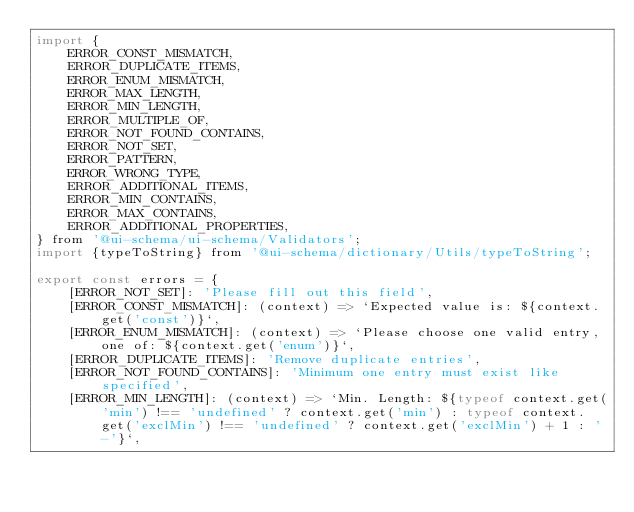Convert code to text. <code><loc_0><loc_0><loc_500><loc_500><_JavaScript_>import {
    ERROR_CONST_MISMATCH,
    ERROR_DUPLICATE_ITEMS,
    ERROR_ENUM_MISMATCH,
    ERROR_MAX_LENGTH,
    ERROR_MIN_LENGTH,
    ERROR_MULTIPLE_OF,
    ERROR_NOT_FOUND_CONTAINS,
    ERROR_NOT_SET,
    ERROR_PATTERN,
    ERROR_WRONG_TYPE,
    ERROR_ADDITIONAL_ITEMS,
    ERROR_MIN_CONTAINS,
    ERROR_MAX_CONTAINS,
    ERROR_ADDITIONAL_PROPERTIES,
} from '@ui-schema/ui-schema/Validators';
import {typeToString} from '@ui-schema/dictionary/Utils/typeToString';

export const errors = {
    [ERROR_NOT_SET]: 'Please fill out this field',
    [ERROR_CONST_MISMATCH]: (context) => `Expected value is: ${context.get('const')}`,
    [ERROR_ENUM_MISMATCH]: (context) => `Please choose one valid entry, one of: ${context.get('enum')}`,
    [ERROR_DUPLICATE_ITEMS]: 'Remove duplicate entries',
    [ERROR_NOT_FOUND_CONTAINS]: 'Minimum one entry must exist like specified',
    [ERROR_MIN_LENGTH]: (context) => `Min. Length: ${typeof context.get('min') !== 'undefined' ? context.get('min') : typeof context.get('exclMin') !== 'undefined' ? context.get('exclMin') + 1 : '-'}`,</code> 